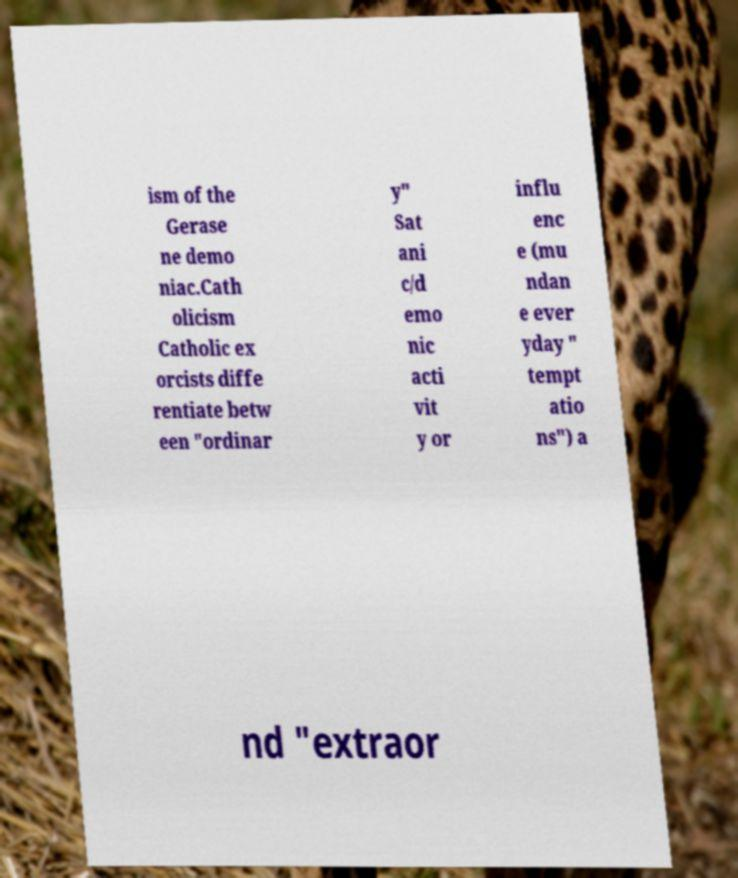Can you read and provide the text displayed in the image?This photo seems to have some interesting text. Can you extract and type it out for me? ism of the Gerase ne demo niac.Cath olicism Catholic ex orcists diffe rentiate betw een "ordinar y" Sat ani c/d emo nic acti vit y or influ enc e (mu ndan e ever yday " tempt atio ns") a nd "extraor 